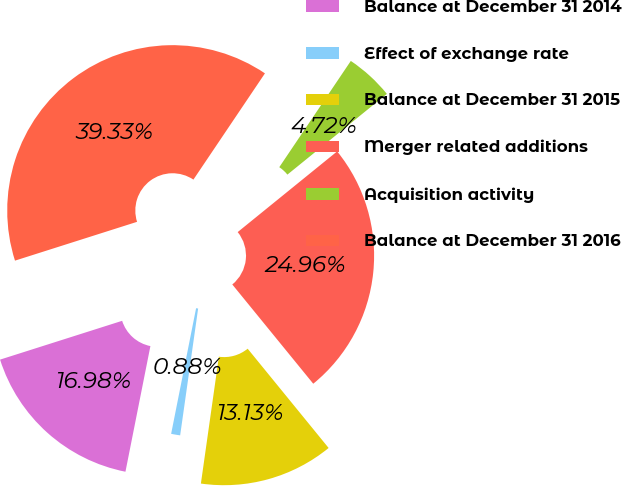<chart> <loc_0><loc_0><loc_500><loc_500><pie_chart><fcel>Balance at December 31 2014<fcel>Effect of exchange rate<fcel>Balance at December 31 2015<fcel>Merger related additions<fcel>Acquisition activity<fcel>Balance at December 31 2016<nl><fcel>16.98%<fcel>0.88%<fcel>13.13%<fcel>24.96%<fcel>4.72%<fcel>39.33%<nl></chart> 